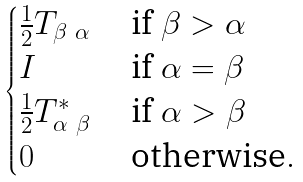Convert formula to latex. <formula><loc_0><loc_0><loc_500><loc_500>\begin{cases} \frac { 1 } { 2 } T _ { \beta \ \alpha } & \text { if } \beta > \alpha \\ I & \text { if } \alpha = \beta \\ \frac { 1 } { 2 } T _ { \alpha \ \beta } ^ { * } & \text { if } \alpha > \beta \\ 0 \quad & \text { otherwise} . \end{cases}</formula> 